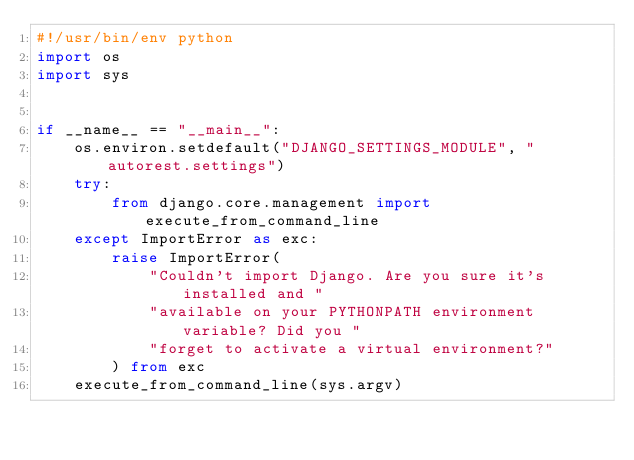<code> <loc_0><loc_0><loc_500><loc_500><_Python_>#!/usr/bin/env python
import os
import sys


if __name__ == "__main__":
    os.environ.setdefault("DJANGO_SETTINGS_MODULE", "autorest.settings")
    try:
        from django.core.management import execute_from_command_line
    except ImportError as exc:
        raise ImportError(
            "Couldn't import Django. Are you sure it's installed and "
            "available on your PYTHONPATH environment variable? Did you "
            "forget to activate a virtual environment?"
        ) from exc
    execute_from_command_line(sys.argv)
</code> 